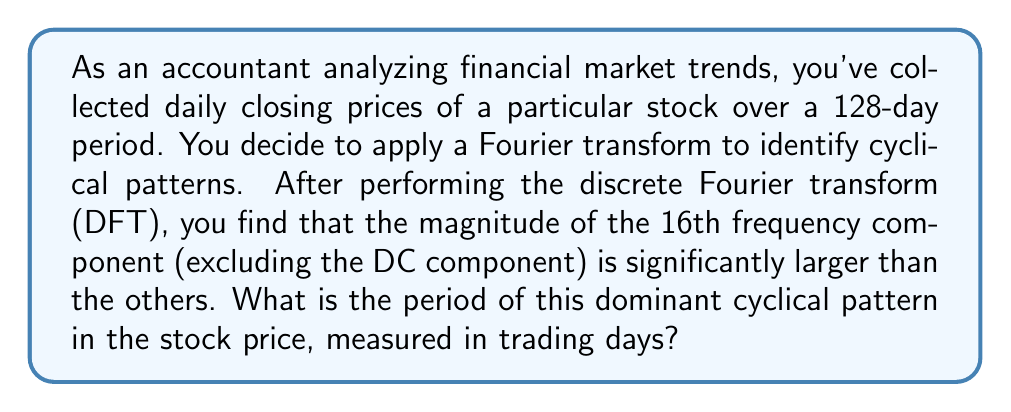Can you answer this question? Let's approach this step-by-step:

1) In a discrete Fourier transform of N points, the k-th frequency component corresponds to a frequency of $\frac{k}{N}$ cycles per sample.

2) We're given that N = 128 days, and the significant component is the 16th (excluding DC).

3) The frequency of this component is:

   $$f = \frac{16}{128} = \frac{1}{8}$$ cycles per day

4) To find the period, we take the reciprocal of the frequency:

   $$T = \frac{1}{f} = \frac{1}{\frac{1}{8}} = 8$$ days

5) Therefore, the dominant cyclical pattern repeats every 8 trading days.

This analysis could be particularly useful in comparing market behaviors between different countries, as cyclical patterns might vary due to different economic policies, trading hours, or cultural factors affecting market sentiment.
Answer: 8 trading days 